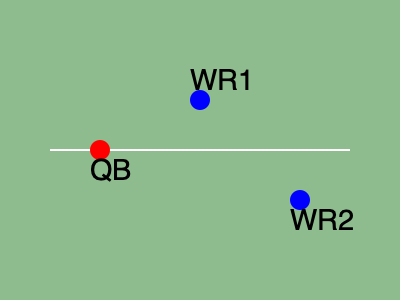In this bird's-eye view of a passing play, estimate the distance between the two wide receivers (WR1 and WR2) if the quarterback (QB) is 10 yards behind the line of scrimmage and the distance between the QB and WR1 is approximately 15 yards. To estimate the distance between WR1 and WR2, we can use the Pythagorean theorem and the given information:

1. QB is 10 yards behind the line of scrimmage.
2. Distance between QB and WR1 is approximately 15 yards.

Step 1: Determine the relative positions of the players.
- QB is at (0, 0)
- WR1 is approximately at (10, 11.18) based on the 15-yard distance from QB
- WR2 appears to be about 20 yards downfield and 10 yards to the right of QB

Step 2: Calculate the coordinates of WR2.
WR2 is at approximately (10, -20)

Step 3: Use the distance formula (derived from Pythagorean theorem) to calculate the distance between WR1 and WR2.

Distance = $\sqrt{(x_2-x_1)^2 + (y_2-y_1)^2}$

Where $(x_1, y_1)$ is (10, 11.18) and $(x_2, y_2)$ is (10, -20)

Distance = $\sqrt{(10-10)^2 + (-20-11.18)^2}$
         = $\sqrt{0^2 + (-31.18)^2}$
         = $\sqrt{971.79}$
         ≈ 31.17 yards

Step 4: Round to the nearest yard for a practical estimate.

Therefore, the estimated distance between WR1 and WR2 is approximately 31 yards.
Answer: 31 yards 